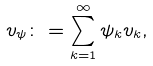<formula> <loc_0><loc_0><loc_500><loc_500>v _ { \psi } \colon = \sum ^ { \infty } _ { k = 1 } \psi _ { k } v _ { k } ,</formula> 